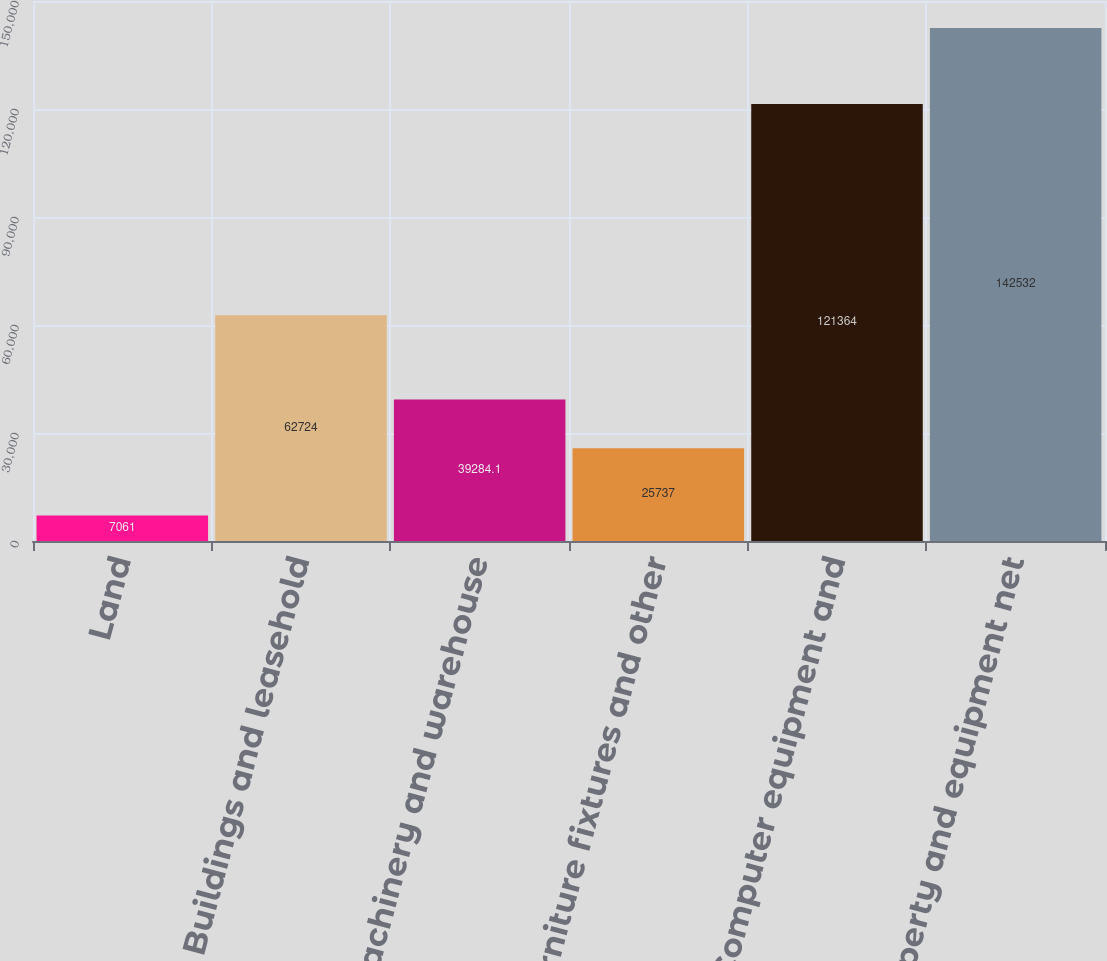Convert chart. <chart><loc_0><loc_0><loc_500><loc_500><bar_chart><fcel>Land<fcel>Buildings and leasehold<fcel>Machinery and warehouse<fcel>Furniture fixtures and other<fcel>Computer equipment and<fcel>Property and equipment net<nl><fcel>7061<fcel>62724<fcel>39284.1<fcel>25737<fcel>121364<fcel>142532<nl></chart> 